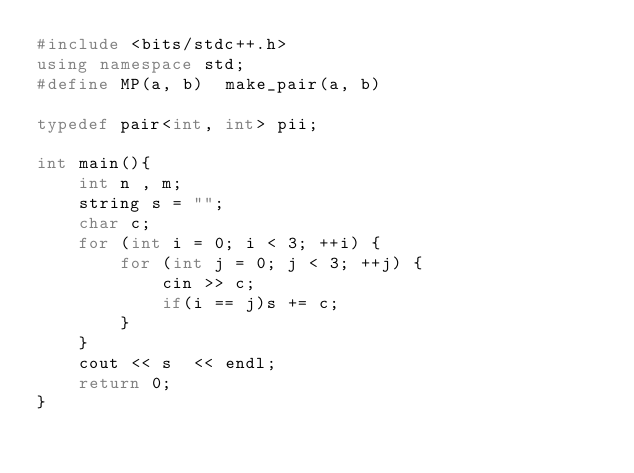Convert code to text. <code><loc_0><loc_0><loc_500><loc_500><_C++_>#include <bits/stdc++.h>
using namespace std;
#define MP(a, b)  make_pair(a, b)

typedef pair<int, int> pii;

int main(){
    int n , m;
    string s = "";
    char c;
    for (int i = 0; i < 3; ++i) {
        for (int j = 0; j < 3; ++j) {
            cin >> c;
            if(i == j)s += c;
        }
    }
    cout << s  << endl;
    return 0;
}</code> 